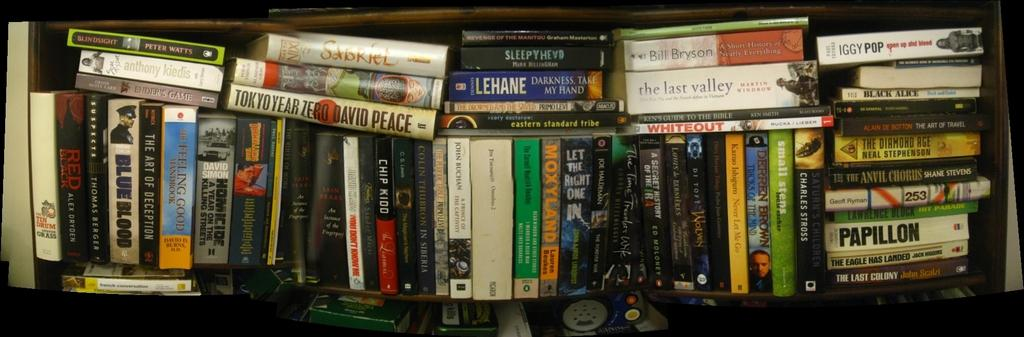<image>
Give a short and clear explanation of the subsequent image. a book that says Papillon among many other books 